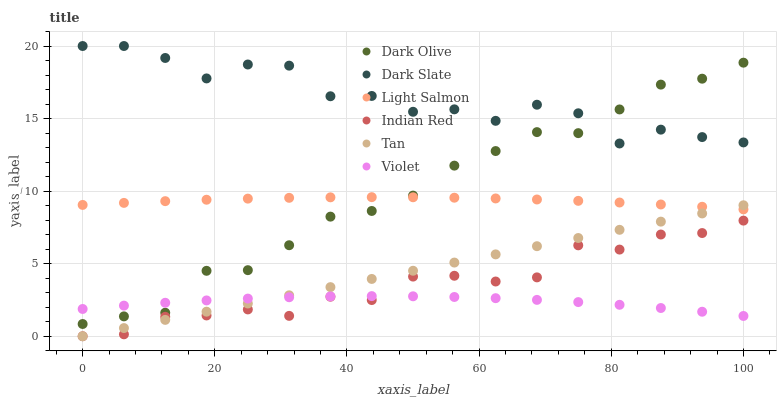Does Violet have the minimum area under the curve?
Answer yes or no. Yes. Does Dark Slate have the maximum area under the curve?
Answer yes or no. Yes. Does Dark Olive have the minimum area under the curve?
Answer yes or no. No. Does Dark Olive have the maximum area under the curve?
Answer yes or no. No. Is Tan the smoothest?
Answer yes or no. Yes. Is Dark Slate the roughest?
Answer yes or no. Yes. Is Dark Olive the smoothest?
Answer yes or no. No. Is Dark Olive the roughest?
Answer yes or no. No. Does Indian Red have the lowest value?
Answer yes or no. Yes. Does Dark Olive have the lowest value?
Answer yes or no. No. Does Dark Slate have the highest value?
Answer yes or no. Yes. Does Dark Olive have the highest value?
Answer yes or no. No. Is Violet less than Light Salmon?
Answer yes or no. Yes. Is Dark Slate greater than Indian Red?
Answer yes or no. Yes. Does Light Salmon intersect Dark Olive?
Answer yes or no. Yes. Is Light Salmon less than Dark Olive?
Answer yes or no. No. Is Light Salmon greater than Dark Olive?
Answer yes or no. No. Does Violet intersect Light Salmon?
Answer yes or no. No. 